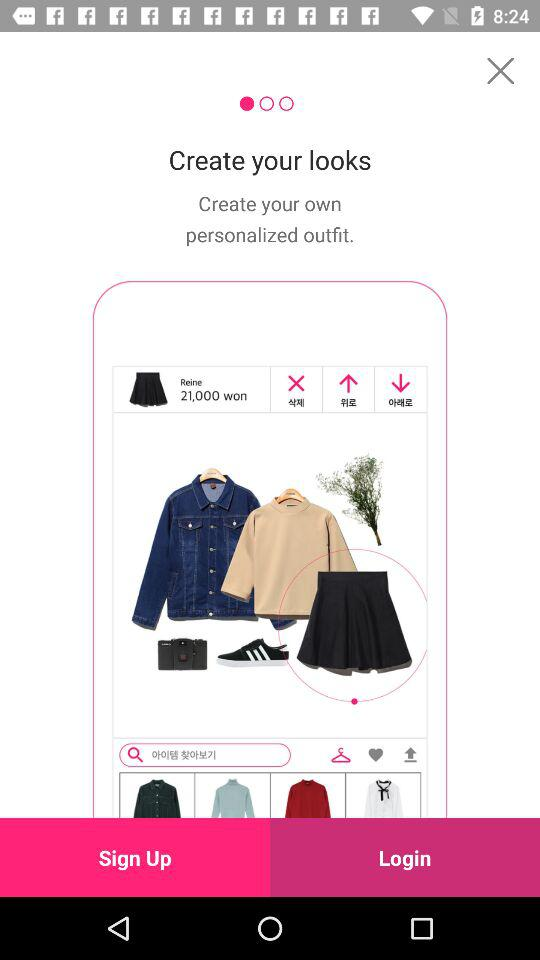What is the price of Reine? The price is 21,000 won. 